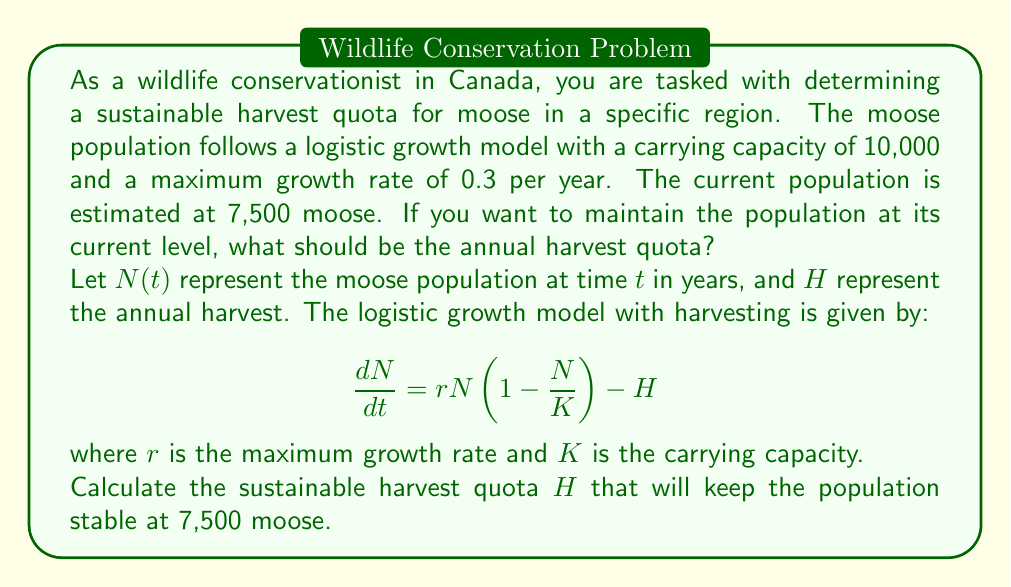Can you solve this math problem? To solve this problem, we need to follow these steps:

1. Understand the given parameters:
   - Carrying capacity, $K = 10,000$
   - Maximum growth rate, $r = 0.3$ per year
   - Current population, $N = 7,500$

2. For a stable population, we want $\frac{dN}{dt} = 0$. This means the population growth should equal the harvest:

   $$rN(1-\frac{N}{K}) = H$$

3. Substitute the known values into the equation:

   $$0.3 \cdot 7,500 \cdot (1-\frac{7,500}{10,000}) = H$$

4. Simplify the expression:
   
   $$0.3 \cdot 7,500 \cdot (1-0.75) = H$$
   $$0.3 \cdot 7,500 \cdot 0.25 = H$$
   $$2,250 \cdot 0.25 = H$$
   $$562.5 = H$$

5. Since we can't harvest fractional moose, we round down to the nearest whole number for a conservative estimate.

Therefore, the sustainable annual harvest quota should be 562 moose.

This quota ensures that the population remains stable at 7,500 moose, balancing the natural growth with hunting pressure. It's important to note that this model assumes ideal conditions and should be adjusted based on other factors such as predation, disease, and environmental changes.
Answer: The sustainable annual harvest quota for moose in this region should be 562 animals. 